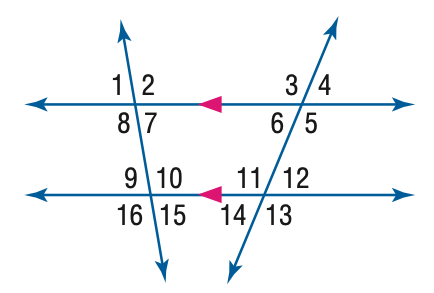Identifying patterns in the image, what is the relationship between angle 7 and angle 9? The relationship between angle 7 and angle 9 is that of vertical angles. Vertical angles are pairs of opposite angles made by two intersecting lines, and they are always equal. Therefore, m \angle 7 is equal to m \angle 9. 